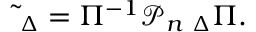Convert formula to latex. <formula><loc_0><loc_0><loc_500><loc_500>\widetilde { \Phi } _ { \Delta } = \Pi ^ { - 1 } { \mathcal { P } } _ { n } { \Phi } _ { \Delta } \Pi .</formula> 